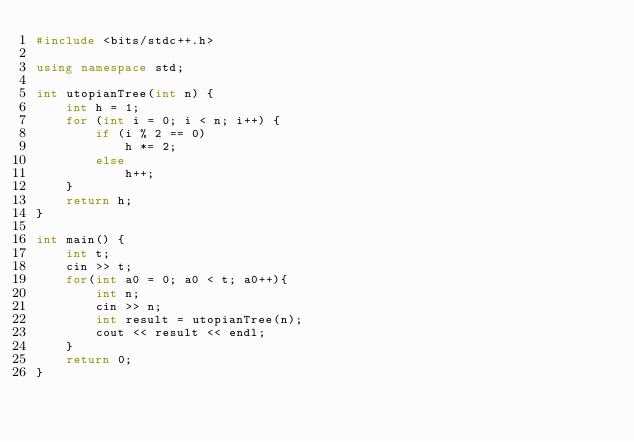<code> <loc_0><loc_0><loc_500><loc_500><_C++_>#include <bits/stdc++.h>

using namespace std;

int utopianTree(int n) {
    int h = 1;
    for (int i = 0; i < n; i++) {
        if (i % 2 == 0)
            h *= 2;
        else
            h++;
    }
    return h;
}

int main() {
    int t;
    cin >> t;
    for(int a0 = 0; a0 < t; a0++){
        int n;
        cin >> n;
        int result = utopianTree(n);
        cout << result << endl;
    }
    return 0;
}
</code> 